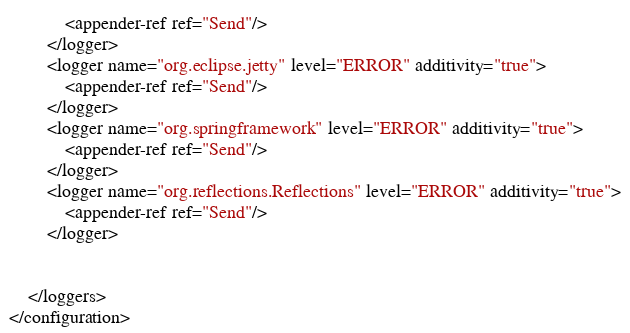<code> <loc_0><loc_0><loc_500><loc_500><_XML_>            <appender-ref ref="Send"/>
        </logger>
        <logger name="org.eclipse.jetty" level="ERROR" additivity="true">
            <appender-ref ref="Send"/>
        </logger>
        <logger name="org.springframework" level="ERROR" additivity="true">
            <appender-ref ref="Send"/>
        </logger>
        <logger name="org.reflections.Reflections" level="ERROR" additivity="true">
            <appender-ref ref="Send"/>
        </logger>


    </loggers>
</configuration>
</code> 